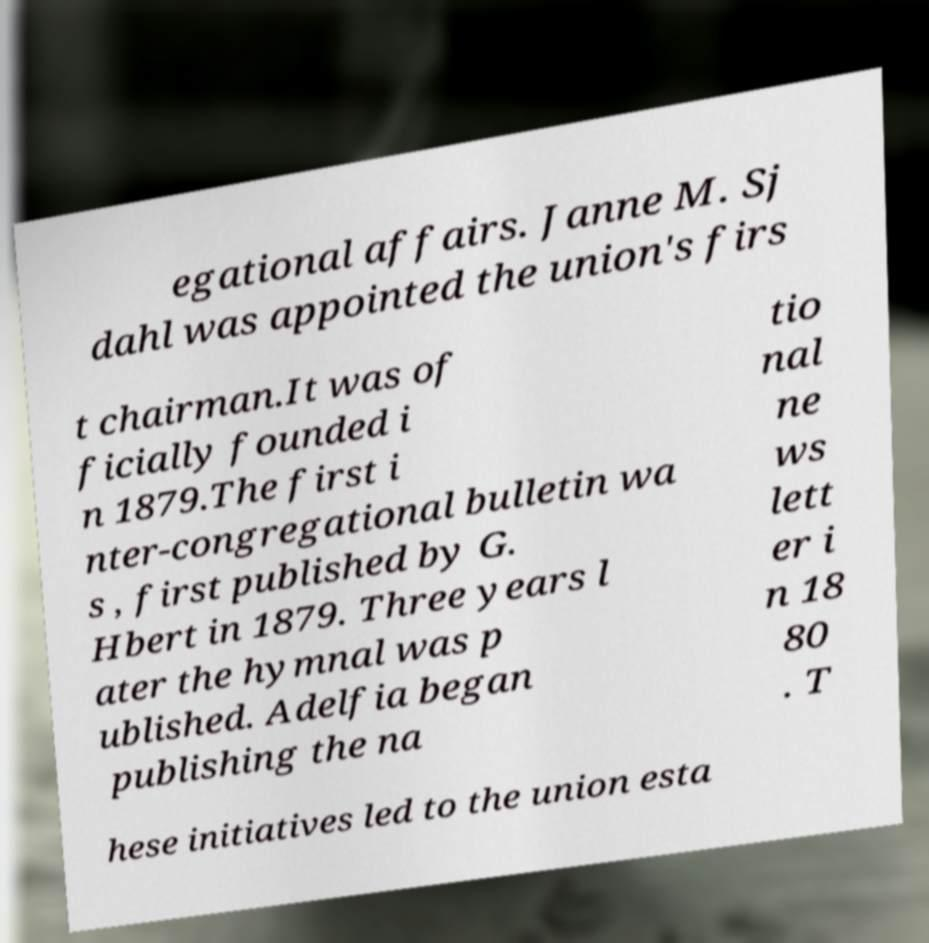There's text embedded in this image that I need extracted. Can you transcribe it verbatim? egational affairs. Janne M. Sj dahl was appointed the union's firs t chairman.It was of ficially founded i n 1879.The first i nter-congregational bulletin wa s , first published by G. Hbert in 1879. Three years l ater the hymnal was p ublished. Adelfia began publishing the na tio nal ne ws lett er i n 18 80 . T hese initiatives led to the union esta 